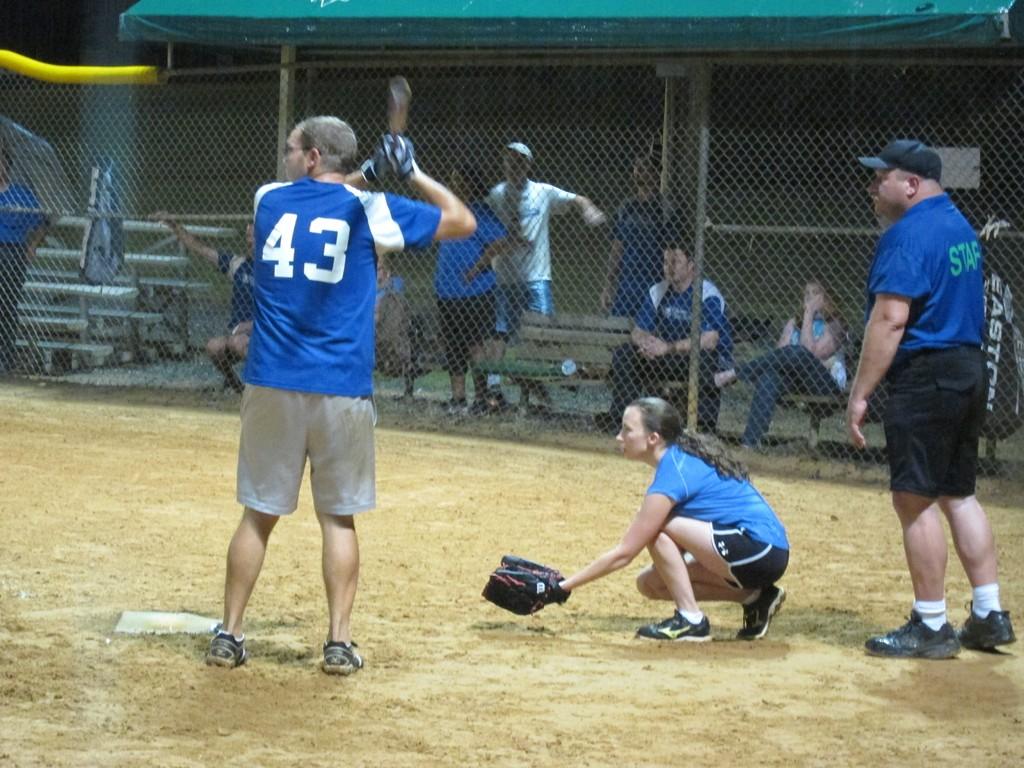Are these guys playing baseball?
Make the answer very short. Answering does not require reading text in the image. 